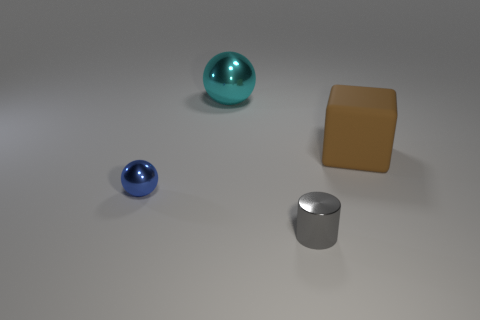Add 1 large blue metallic cylinders. How many objects exist? 5 Subtract all blocks. How many objects are left? 3 Add 1 tiny blue metallic things. How many tiny blue metallic things are left? 2 Add 4 small objects. How many small objects exist? 6 Subtract 0 yellow cubes. How many objects are left? 4 Subtract all small gray metallic cylinders. Subtract all brown matte objects. How many objects are left? 2 